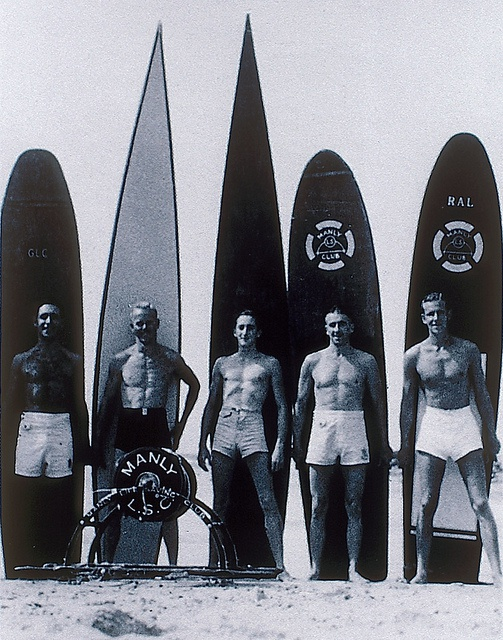Describe the objects in this image and their specific colors. I can see people in white, black, lightgray, darkgray, and gray tones, surfboard in white, black, darkgray, gray, and lightgray tones, surfboard in white, black, darkgray, and gray tones, surfboard in white, black, gray, and darkblue tones, and surfboard in white, darkgray, black, and gray tones in this image. 